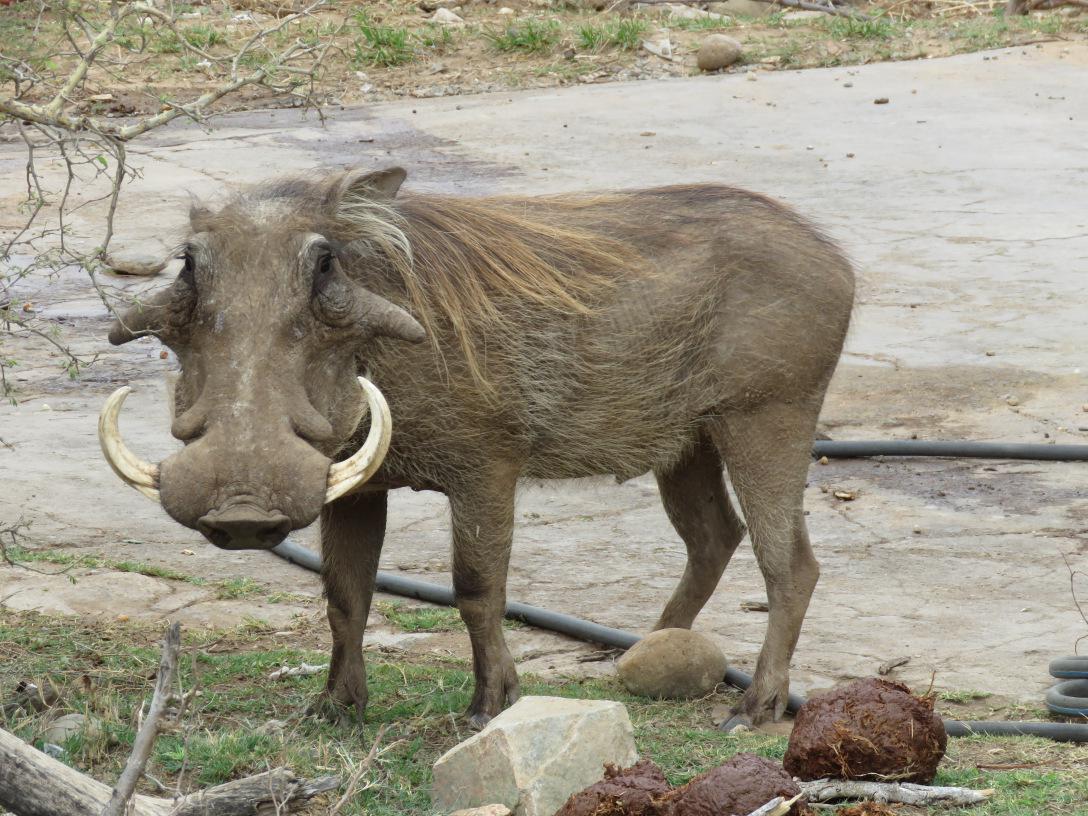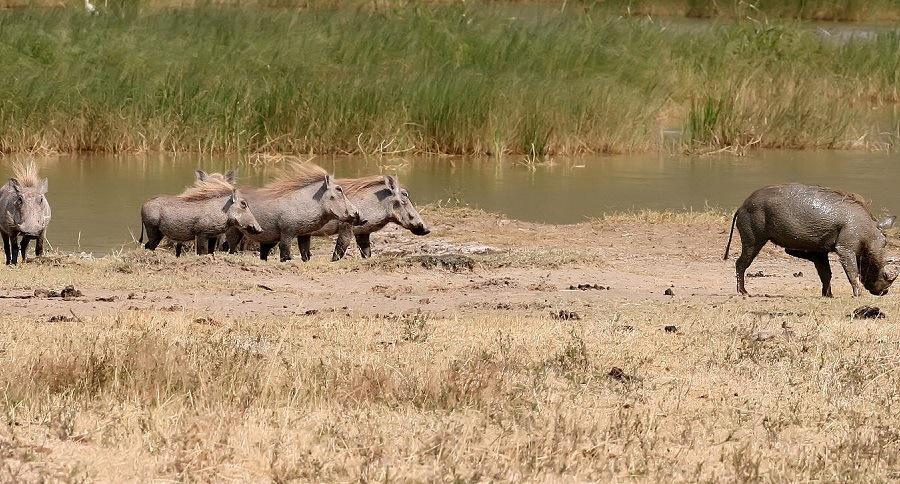The first image is the image on the left, the second image is the image on the right. Examine the images to the left and right. Is the description "In one of the images there is a group of warthogs standing near water." accurate? Answer yes or no. Yes. 